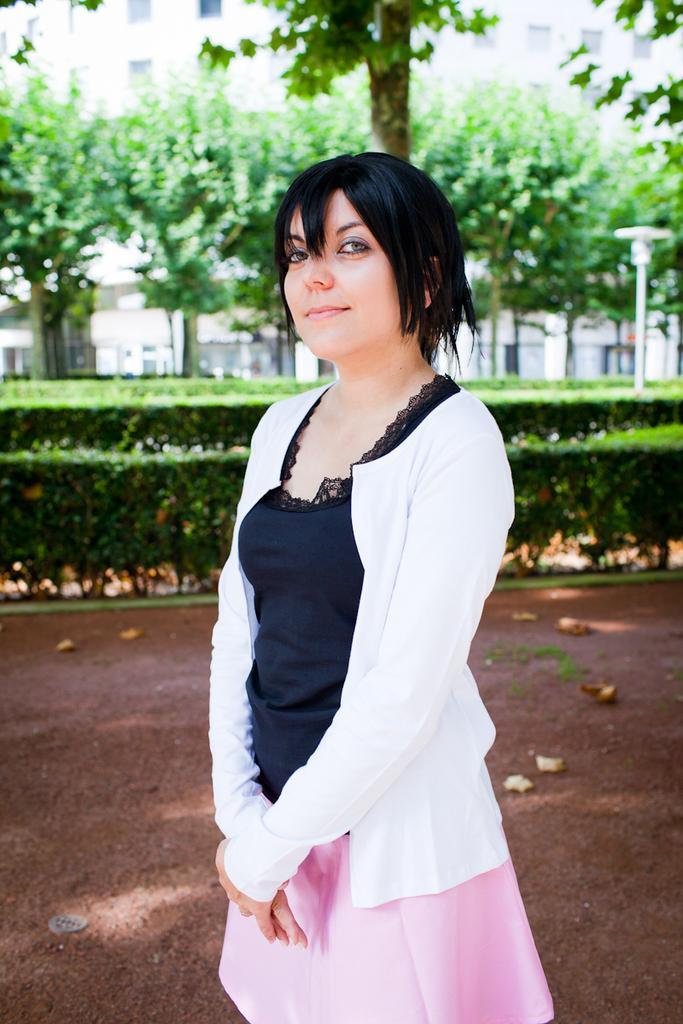In one or two sentences, can you explain what this image depicts? In the foreground of this image, there is a woman standing wearing skirt and a white shirt. In the background, there is land, few plants, trees, a pole on the right and a building. 